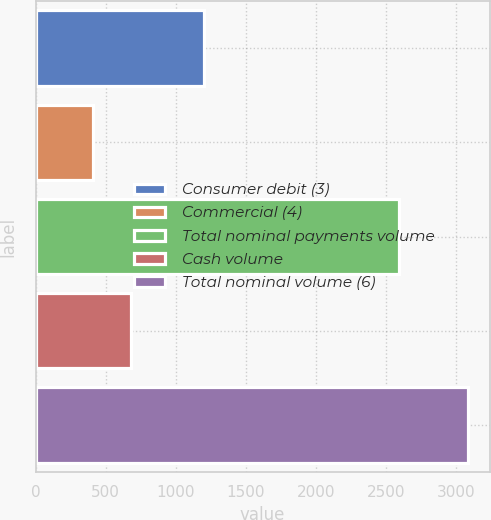Convert chart. <chart><loc_0><loc_0><loc_500><loc_500><bar_chart><fcel>Consumer debit (3)<fcel>Commercial (4)<fcel>Total nominal payments volume<fcel>Cash volume<fcel>Total nominal volume (6)<nl><fcel>1202<fcel>412<fcel>2594<fcel>679.4<fcel>3086<nl></chart> 